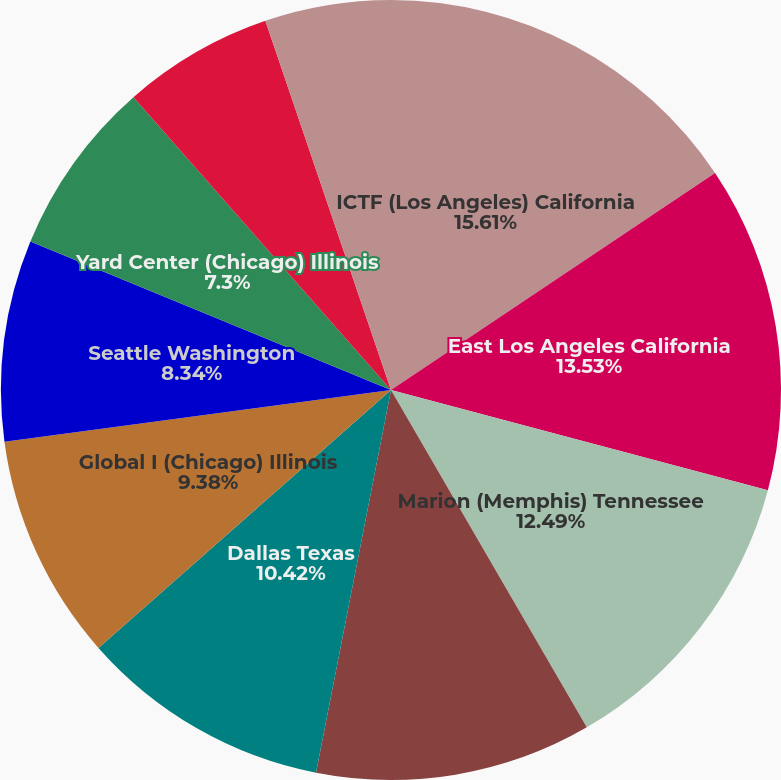Convert chart to OTSL. <chart><loc_0><loc_0><loc_500><loc_500><pie_chart><fcel>ICTF (Los Angeles) California<fcel>East Los Angeles California<fcel>Marion (Memphis) Tennessee<fcel>Global II (Chicago) Illinois<fcel>Dallas Texas<fcel>Global I (Chicago) Illinois<fcel>Seattle Washington<fcel>Yard Center (Chicago) Illinois<fcel>Oakland California<fcel>Englewood (Houston) Texas<nl><fcel>15.61%<fcel>13.53%<fcel>12.49%<fcel>11.45%<fcel>10.42%<fcel>9.38%<fcel>8.34%<fcel>7.3%<fcel>6.26%<fcel>5.22%<nl></chart> 